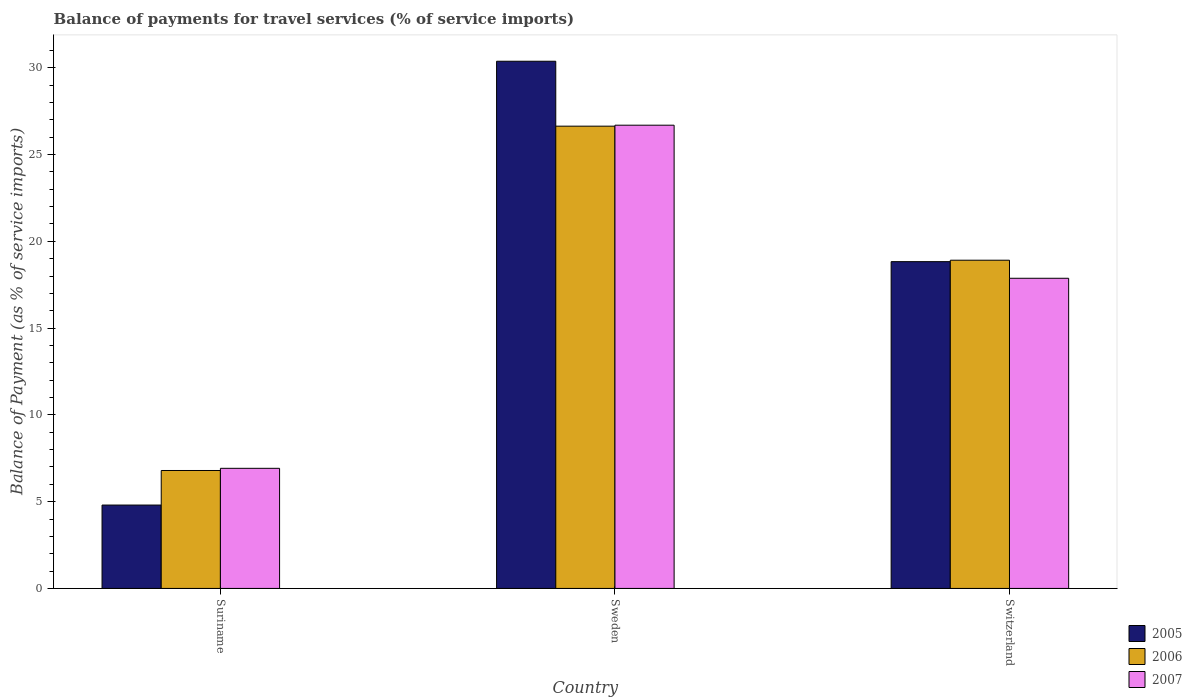How many different coloured bars are there?
Your response must be concise. 3. How many groups of bars are there?
Keep it short and to the point. 3. Are the number of bars per tick equal to the number of legend labels?
Offer a terse response. Yes. Are the number of bars on each tick of the X-axis equal?
Provide a succinct answer. Yes. How many bars are there on the 2nd tick from the left?
Offer a terse response. 3. How many bars are there on the 2nd tick from the right?
Your answer should be very brief. 3. What is the label of the 3rd group of bars from the left?
Give a very brief answer. Switzerland. In how many cases, is the number of bars for a given country not equal to the number of legend labels?
Give a very brief answer. 0. What is the balance of payments for travel services in 2007 in Switzerland?
Make the answer very short. 17.87. Across all countries, what is the maximum balance of payments for travel services in 2007?
Your response must be concise. 26.69. Across all countries, what is the minimum balance of payments for travel services in 2007?
Your answer should be compact. 6.92. In which country was the balance of payments for travel services in 2005 minimum?
Keep it short and to the point. Suriname. What is the total balance of payments for travel services in 2006 in the graph?
Make the answer very short. 52.34. What is the difference between the balance of payments for travel services in 2005 in Sweden and that in Switzerland?
Make the answer very short. 11.55. What is the difference between the balance of payments for travel services in 2005 in Switzerland and the balance of payments for travel services in 2006 in Suriname?
Make the answer very short. 12.03. What is the average balance of payments for travel services in 2007 per country?
Your response must be concise. 17.16. What is the difference between the balance of payments for travel services of/in 2005 and balance of payments for travel services of/in 2006 in Sweden?
Offer a terse response. 3.74. What is the ratio of the balance of payments for travel services in 2005 in Suriname to that in Switzerland?
Provide a succinct answer. 0.26. What is the difference between the highest and the second highest balance of payments for travel services in 2006?
Provide a succinct answer. 7.72. What is the difference between the highest and the lowest balance of payments for travel services in 2005?
Provide a succinct answer. 25.57. What does the 2nd bar from the right in Switzerland represents?
Offer a very short reply. 2006. How many bars are there?
Offer a terse response. 9. Are the values on the major ticks of Y-axis written in scientific E-notation?
Give a very brief answer. No. What is the title of the graph?
Your answer should be compact. Balance of payments for travel services (% of service imports). Does "1967" appear as one of the legend labels in the graph?
Make the answer very short. No. What is the label or title of the X-axis?
Make the answer very short. Country. What is the label or title of the Y-axis?
Offer a very short reply. Balance of Payment (as % of service imports). What is the Balance of Payment (as % of service imports) in 2005 in Suriname?
Offer a very short reply. 4.8. What is the Balance of Payment (as % of service imports) in 2006 in Suriname?
Provide a succinct answer. 6.8. What is the Balance of Payment (as % of service imports) in 2007 in Suriname?
Your answer should be very brief. 6.92. What is the Balance of Payment (as % of service imports) in 2005 in Sweden?
Offer a terse response. 30.37. What is the Balance of Payment (as % of service imports) in 2006 in Sweden?
Your response must be concise. 26.63. What is the Balance of Payment (as % of service imports) in 2007 in Sweden?
Your answer should be compact. 26.69. What is the Balance of Payment (as % of service imports) of 2005 in Switzerland?
Make the answer very short. 18.83. What is the Balance of Payment (as % of service imports) of 2006 in Switzerland?
Your response must be concise. 18.91. What is the Balance of Payment (as % of service imports) of 2007 in Switzerland?
Offer a terse response. 17.87. Across all countries, what is the maximum Balance of Payment (as % of service imports) in 2005?
Give a very brief answer. 30.37. Across all countries, what is the maximum Balance of Payment (as % of service imports) of 2006?
Make the answer very short. 26.63. Across all countries, what is the maximum Balance of Payment (as % of service imports) of 2007?
Keep it short and to the point. 26.69. Across all countries, what is the minimum Balance of Payment (as % of service imports) of 2005?
Ensure brevity in your answer.  4.8. Across all countries, what is the minimum Balance of Payment (as % of service imports) of 2006?
Provide a short and direct response. 6.8. Across all countries, what is the minimum Balance of Payment (as % of service imports) of 2007?
Your answer should be very brief. 6.92. What is the total Balance of Payment (as % of service imports) of 2005 in the graph?
Your answer should be very brief. 54. What is the total Balance of Payment (as % of service imports) in 2006 in the graph?
Your answer should be very brief. 52.34. What is the total Balance of Payment (as % of service imports) in 2007 in the graph?
Give a very brief answer. 51.48. What is the difference between the Balance of Payment (as % of service imports) in 2005 in Suriname and that in Sweden?
Your answer should be compact. -25.57. What is the difference between the Balance of Payment (as % of service imports) of 2006 in Suriname and that in Sweden?
Make the answer very short. -19.84. What is the difference between the Balance of Payment (as % of service imports) of 2007 in Suriname and that in Sweden?
Keep it short and to the point. -19.77. What is the difference between the Balance of Payment (as % of service imports) of 2005 in Suriname and that in Switzerland?
Provide a succinct answer. -14.02. What is the difference between the Balance of Payment (as % of service imports) of 2006 in Suriname and that in Switzerland?
Keep it short and to the point. -12.12. What is the difference between the Balance of Payment (as % of service imports) in 2007 in Suriname and that in Switzerland?
Offer a terse response. -10.95. What is the difference between the Balance of Payment (as % of service imports) of 2005 in Sweden and that in Switzerland?
Give a very brief answer. 11.55. What is the difference between the Balance of Payment (as % of service imports) in 2006 in Sweden and that in Switzerland?
Provide a succinct answer. 7.72. What is the difference between the Balance of Payment (as % of service imports) of 2007 in Sweden and that in Switzerland?
Give a very brief answer. 8.82. What is the difference between the Balance of Payment (as % of service imports) of 2005 in Suriname and the Balance of Payment (as % of service imports) of 2006 in Sweden?
Provide a short and direct response. -21.83. What is the difference between the Balance of Payment (as % of service imports) in 2005 in Suriname and the Balance of Payment (as % of service imports) in 2007 in Sweden?
Ensure brevity in your answer.  -21.88. What is the difference between the Balance of Payment (as % of service imports) of 2006 in Suriname and the Balance of Payment (as % of service imports) of 2007 in Sweden?
Offer a terse response. -19.89. What is the difference between the Balance of Payment (as % of service imports) of 2005 in Suriname and the Balance of Payment (as % of service imports) of 2006 in Switzerland?
Your answer should be compact. -14.11. What is the difference between the Balance of Payment (as % of service imports) in 2005 in Suriname and the Balance of Payment (as % of service imports) in 2007 in Switzerland?
Ensure brevity in your answer.  -13.07. What is the difference between the Balance of Payment (as % of service imports) of 2006 in Suriname and the Balance of Payment (as % of service imports) of 2007 in Switzerland?
Offer a very short reply. -11.07. What is the difference between the Balance of Payment (as % of service imports) in 2005 in Sweden and the Balance of Payment (as % of service imports) in 2006 in Switzerland?
Provide a succinct answer. 11.46. What is the difference between the Balance of Payment (as % of service imports) in 2005 in Sweden and the Balance of Payment (as % of service imports) in 2007 in Switzerland?
Keep it short and to the point. 12.5. What is the difference between the Balance of Payment (as % of service imports) of 2006 in Sweden and the Balance of Payment (as % of service imports) of 2007 in Switzerland?
Give a very brief answer. 8.76. What is the average Balance of Payment (as % of service imports) of 2005 per country?
Keep it short and to the point. 18. What is the average Balance of Payment (as % of service imports) in 2006 per country?
Provide a succinct answer. 17.45. What is the average Balance of Payment (as % of service imports) of 2007 per country?
Your response must be concise. 17.16. What is the difference between the Balance of Payment (as % of service imports) of 2005 and Balance of Payment (as % of service imports) of 2006 in Suriname?
Your response must be concise. -1.99. What is the difference between the Balance of Payment (as % of service imports) in 2005 and Balance of Payment (as % of service imports) in 2007 in Suriname?
Your answer should be compact. -2.12. What is the difference between the Balance of Payment (as % of service imports) of 2006 and Balance of Payment (as % of service imports) of 2007 in Suriname?
Your answer should be compact. -0.12. What is the difference between the Balance of Payment (as % of service imports) in 2005 and Balance of Payment (as % of service imports) in 2006 in Sweden?
Your answer should be compact. 3.74. What is the difference between the Balance of Payment (as % of service imports) of 2005 and Balance of Payment (as % of service imports) of 2007 in Sweden?
Your answer should be compact. 3.69. What is the difference between the Balance of Payment (as % of service imports) in 2006 and Balance of Payment (as % of service imports) in 2007 in Sweden?
Your answer should be very brief. -0.06. What is the difference between the Balance of Payment (as % of service imports) of 2005 and Balance of Payment (as % of service imports) of 2006 in Switzerland?
Your response must be concise. -0.08. What is the difference between the Balance of Payment (as % of service imports) in 2005 and Balance of Payment (as % of service imports) in 2007 in Switzerland?
Make the answer very short. 0.96. What is the difference between the Balance of Payment (as % of service imports) of 2006 and Balance of Payment (as % of service imports) of 2007 in Switzerland?
Give a very brief answer. 1.04. What is the ratio of the Balance of Payment (as % of service imports) of 2005 in Suriname to that in Sweden?
Your response must be concise. 0.16. What is the ratio of the Balance of Payment (as % of service imports) in 2006 in Suriname to that in Sweden?
Offer a very short reply. 0.26. What is the ratio of the Balance of Payment (as % of service imports) in 2007 in Suriname to that in Sweden?
Your answer should be very brief. 0.26. What is the ratio of the Balance of Payment (as % of service imports) of 2005 in Suriname to that in Switzerland?
Your answer should be very brief. 0.26. What is the ratio of the Balance of Payment (as % of service imports) of 2006 in Suriname to that in Switzerland?
Your response must be concise. 0.36. What is the ratio of the Balance of Payment (as % of service imports) of 2007 in Suriname to that in Switzerland?
Ensure brevity in your answer.  0.39. What is the ratio of the Balance of Payment (as % of service imports) in 2005 in Sweden to that in Switzerland?
Your answer should be compact. 1.61. What is the ratio of the Balance of Payment (as % of service imports) in 2006 in Sweden to that in Switzerland?
Keep it short and to the point. 1.41. What is the ratio of the Balance of Payment (as % of service imports) of 2007 in Sweden to that in Switzerland?
Provide a short and direct response. 1.49. What is the difference between the highest and the second highest Balance of Payment (as % of service imports) of 2005?
Provide a succinct answer. 11.55. What is the difference between the highest and the second highest Balance of Payment (as % of service imports) in 2006?
Offer a very short reply. 7.72. What is the difference between the highest and the second highest Balance of Payment (as % of service imports) in 2007?
Ensure brevity in your answer.  8.82. What is the difference between the highest and the lowest Balance of Payment (as % of service imports) of 2005?
Offer a terse response. 25.57. What is the difference between the highest and the lowest Balance of Payment (as % of service imports) in 2006?
Offer a very short reply. 19.84. What is the difference between the highest and the lowest Balance of Payment (as % of service imports) in 2007?
Provide a succinct answer. 19.77. 